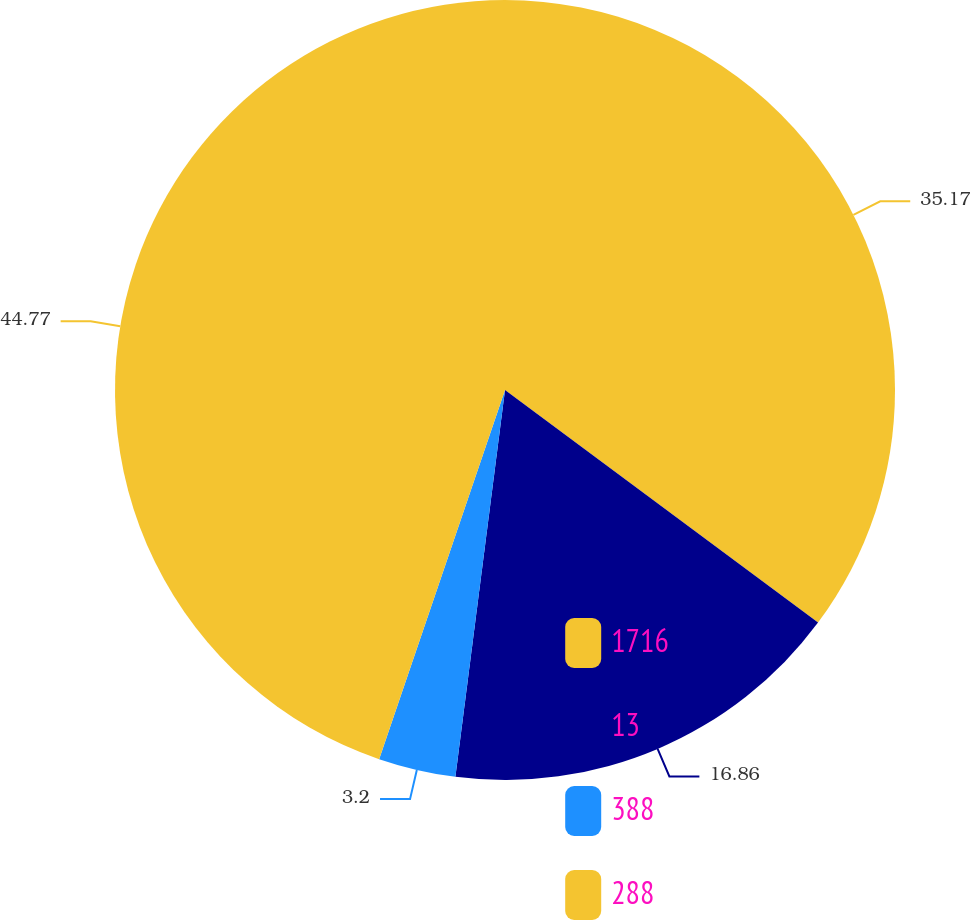Convert chart to OTSL. <chart><loc_0><loc_0><loc_500><loc_500><pie_chart><fcel>1716<fcel>13<fcel>388<fcel>288<nl><fcel>35.17%<fcel>16.86%<fcel>3.2%<fcel>44.77%<nl></chart> 